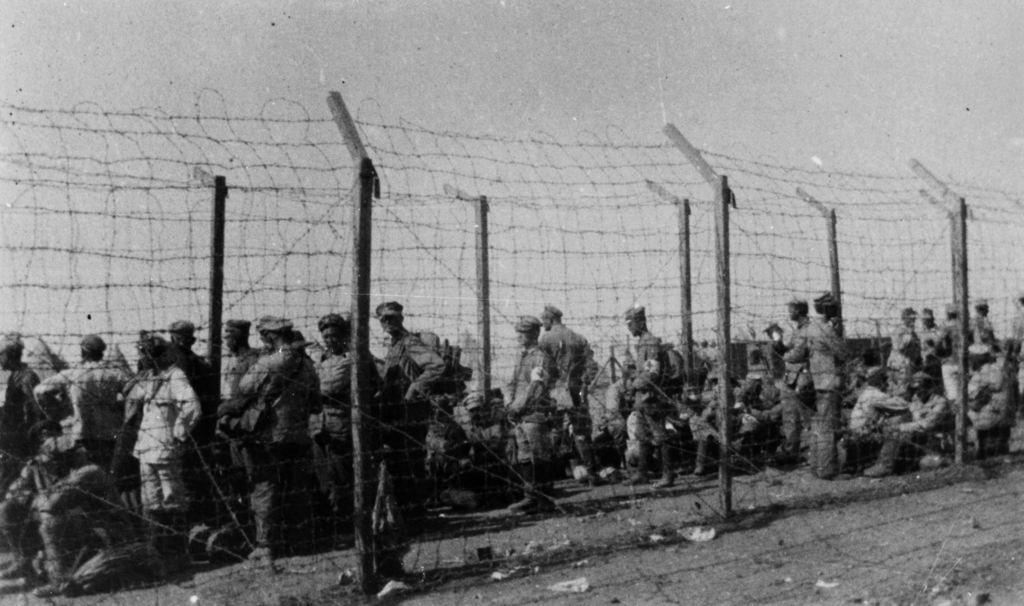What is happening in the image involving people? There is a group of people standing in the image. What can be seen in the image besides the people? There is a fence in the image. What is the color of the soil in the image? The ground has black soil. What is the color scheme of the image? The image is black and white. What is the condition of the sky in the image? The sky is clear in the image. What type of plant is growing on the fence in the image? There is no plant growing on the fence in the image. What color is the chalk used to draw on the ground in the image? There is no chalk or drawing on the ground in the image. 